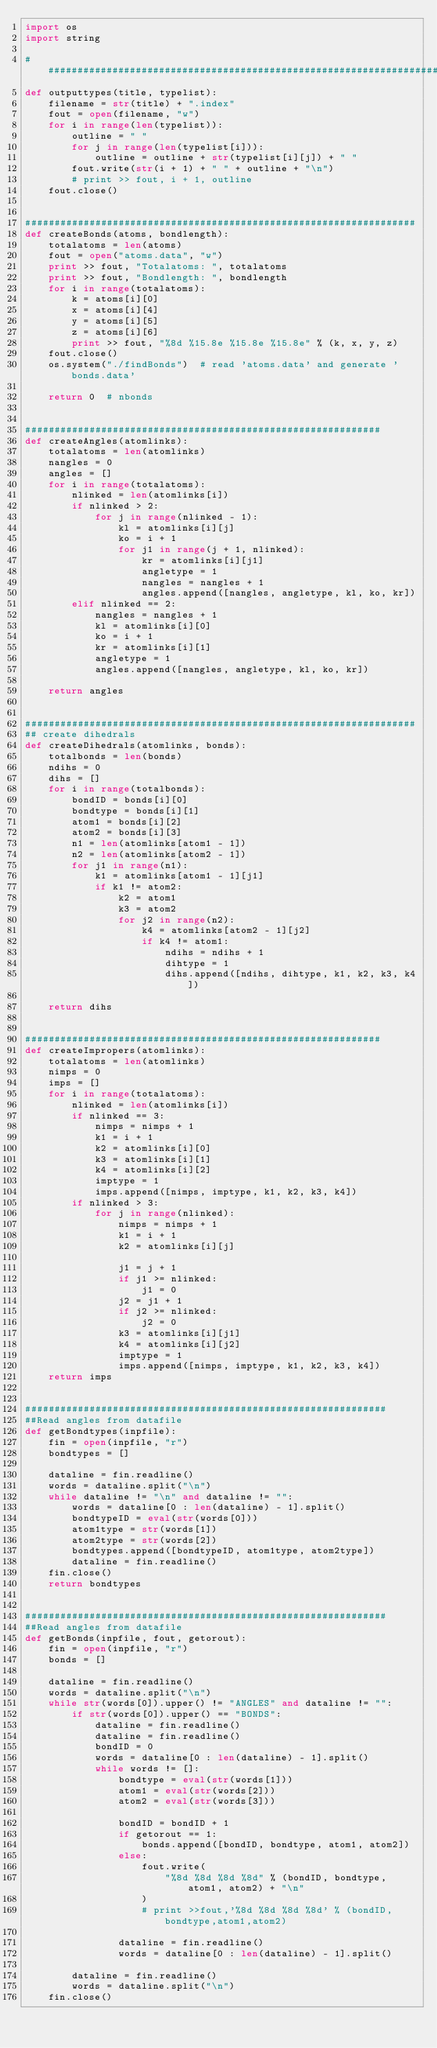Convert code to text. <code><loc_0><loc_0><loc_500><loc_500><_Python_>import os
import string

########################################################################
def outputtypes(title, typelist):
    filename = str(title) + ".index"
    fout = open(filename, "w")
    for i in range(len(typelist)):
        outline = " "
        for j in range(len(typelist[i])):
            outline = outline + str(typelist[i][j]) + " "
        fout.write(str(i + 1) + " " + outline + "\n")
        # print >> fout, i + 1, outline
    fout.close()


###################################################################
def createBonds(atoms, bondlength):
    totalatoms = len(atoms)
    fout = open("atoms.data", "w")
    print >> fout, "Totalatoms: ", totalatoms
    print >> fout, "Bondlength: ", bondlength
    for i in range(totalatoms):
        k = atoms[i][0]
        x = atoms[i][4]
        y = atoms[i][5]
        z = atoms[i][6]
        print >> fout, "%8d %15.8e %15.8e %15.8e" % (k, x, y, z)
    fout.close()
    os.system("./findBonds")  # read 'atoms.data' and generate 'bonds.data'

    return 0  # nbonds


#############################################################
def createAngles(atomlinks):
    totalatoms = len(atomlinks)
    nangles = 0
    angles = []
    for i in range(totalatoms):
        nlinked = len(atomlinks[i])
        if nlinked > 2:
            for j in range(nlinked - 1):
                kl = atomlinks[i][j]
                ko = i + 1
                for j1 in range(j + 1, nlinked):
                    kr = atomlinks[i][j1]
                    angletype = 1
                    nangles = nangles + 1
                    angles.append([nangles, angletype, kl, ko, kr])
        elif nlinked == 2:
            nangles = nangles + 1
            kl = atomlinks[i][0]
            ko = i + 1
            kr = atomlinks[i][1]
            angletype = 1
            angles.append([nangles, angletype, kl, ko, kr])

    return angles


###################################################################
## create dihedrals
def createDihedrals(atomlinks, bonds):
    totalbonds = len(bonds)
    ndihs = 0
    dihs = []
    for i in range(totalbonds):
        bondID = bonds[i][0]
        bondtype = bonds[i][1]
        atom1 = bonds[i][2]
        atom2 = bonds[i][3]
        n1 = len(atomlinks[atom1 - 1])
        n2 = len(atomlinks[atom2 - 1])
        for j1 in range(n1):
            k1 = atomlinks[atom1 - 1][j1]
            if k1 != atom2:
                k2 = atom1
                k3 = atom2
                for j2 in range(n2):
                    k4 = atomlinks[atom2 - 1][j2]
                    if k4 != atom1:
                        ndihs = ndihs + 1
                        dihtype = 1
                        dihs.append([ndihs, dihtype, k1, k2, k3, k4])

    return dihs


#############################################################
def createImpropers(atomlinks):
    totalatoms = len(atomlinks)
    nimps = 0
    imps = []
    for i in range(totalatoms):
        nlinked = len(atomlinks[i])
        if nlinked == 3:
            nimps = nimps + 1
            k1 = i + 1
            k2 = atomlinks[i][0]
            k3 = atomlinks[i][1]
            k4 = atomlinks[i][2]
            imptype = 1
            imps.append([nimps, imptype, k1, k2, k3, k4])
        if nlinked > 3:
            for j in range(nlinked):
                nimps = nimps + 1
                k1 = i + 1
                k2 = atomlinks[i][j]

                j1 = j + 1
                if j1 >= nlinked:
                    j1 = 0
                j2 = j1 + 1
                if j2 >= nlinked:
                    j2 = 0
                k3 = atomlinks[i][j1]
                k4 = atomlinks[i][j2]
                imptype = 1
                imps.append([nimps, imptype, k1, k2, k3, k4])
    return imps


##############################################################
##Read angles from datafile
def getBondtypes(inpfile):
    fin = open(inpfile, "r")
    bondtypes = []

    dataline = fin.readline()
    words = dataline.split("\n")
    while dataline != "\n" and dataline != "":
        words = dataline[0 : len(dataline) - 1].split()
        bondtypeID = eval(str(words[0]))
        atom1type = str(words[1])
        atom2type = str(words[2])
        bondtypes.append([bondtypeID, atom1type, atom2type])
        dataline = fin.readline()
    fin.close()
    return bondtypes


##############################################################
##Read angles from datafile
def getBonds(inpfile, fout, getorout):
    fin = open(inpfile, "r")
    bonds = []

    dataline = fin.readline()
    words = dataline.split("\n")
    while str(words[0]).upper() != "ANGLES" and dataline != "":
        if str(words[0]).upper() == "BONDS":
            dataline = fin.readline()
            dataline = fin.readline()
            bondID = 0
            words = dataline[0 : len(dataline) - 1].split()
            while words != []:
                bondtype = eval(str(words[1]))
                atom1 = eval(str(words[2]))
                atom2 = eval(str(words[3]))

                bondID = bondID + 1
                if getorout == 1:
                    bonds.append([bondID, bondtype, atom1, atom2])
                else:
                    fout.write(
                        "%8d %8d %8d %8d" % (bondID, bondtype, atom1, atom2) + "\n"
                    )
                    # print >>fout,'%8d %8d %8d %8d' % (bondID,bondtype,atom1,atom2)

                dataline = fin.readline()
                words = dataline[0 : len(dataline) - 1].split()

        dataline = fin.readline()
        words = dataline.split("\n")
    fin.close()</code> 